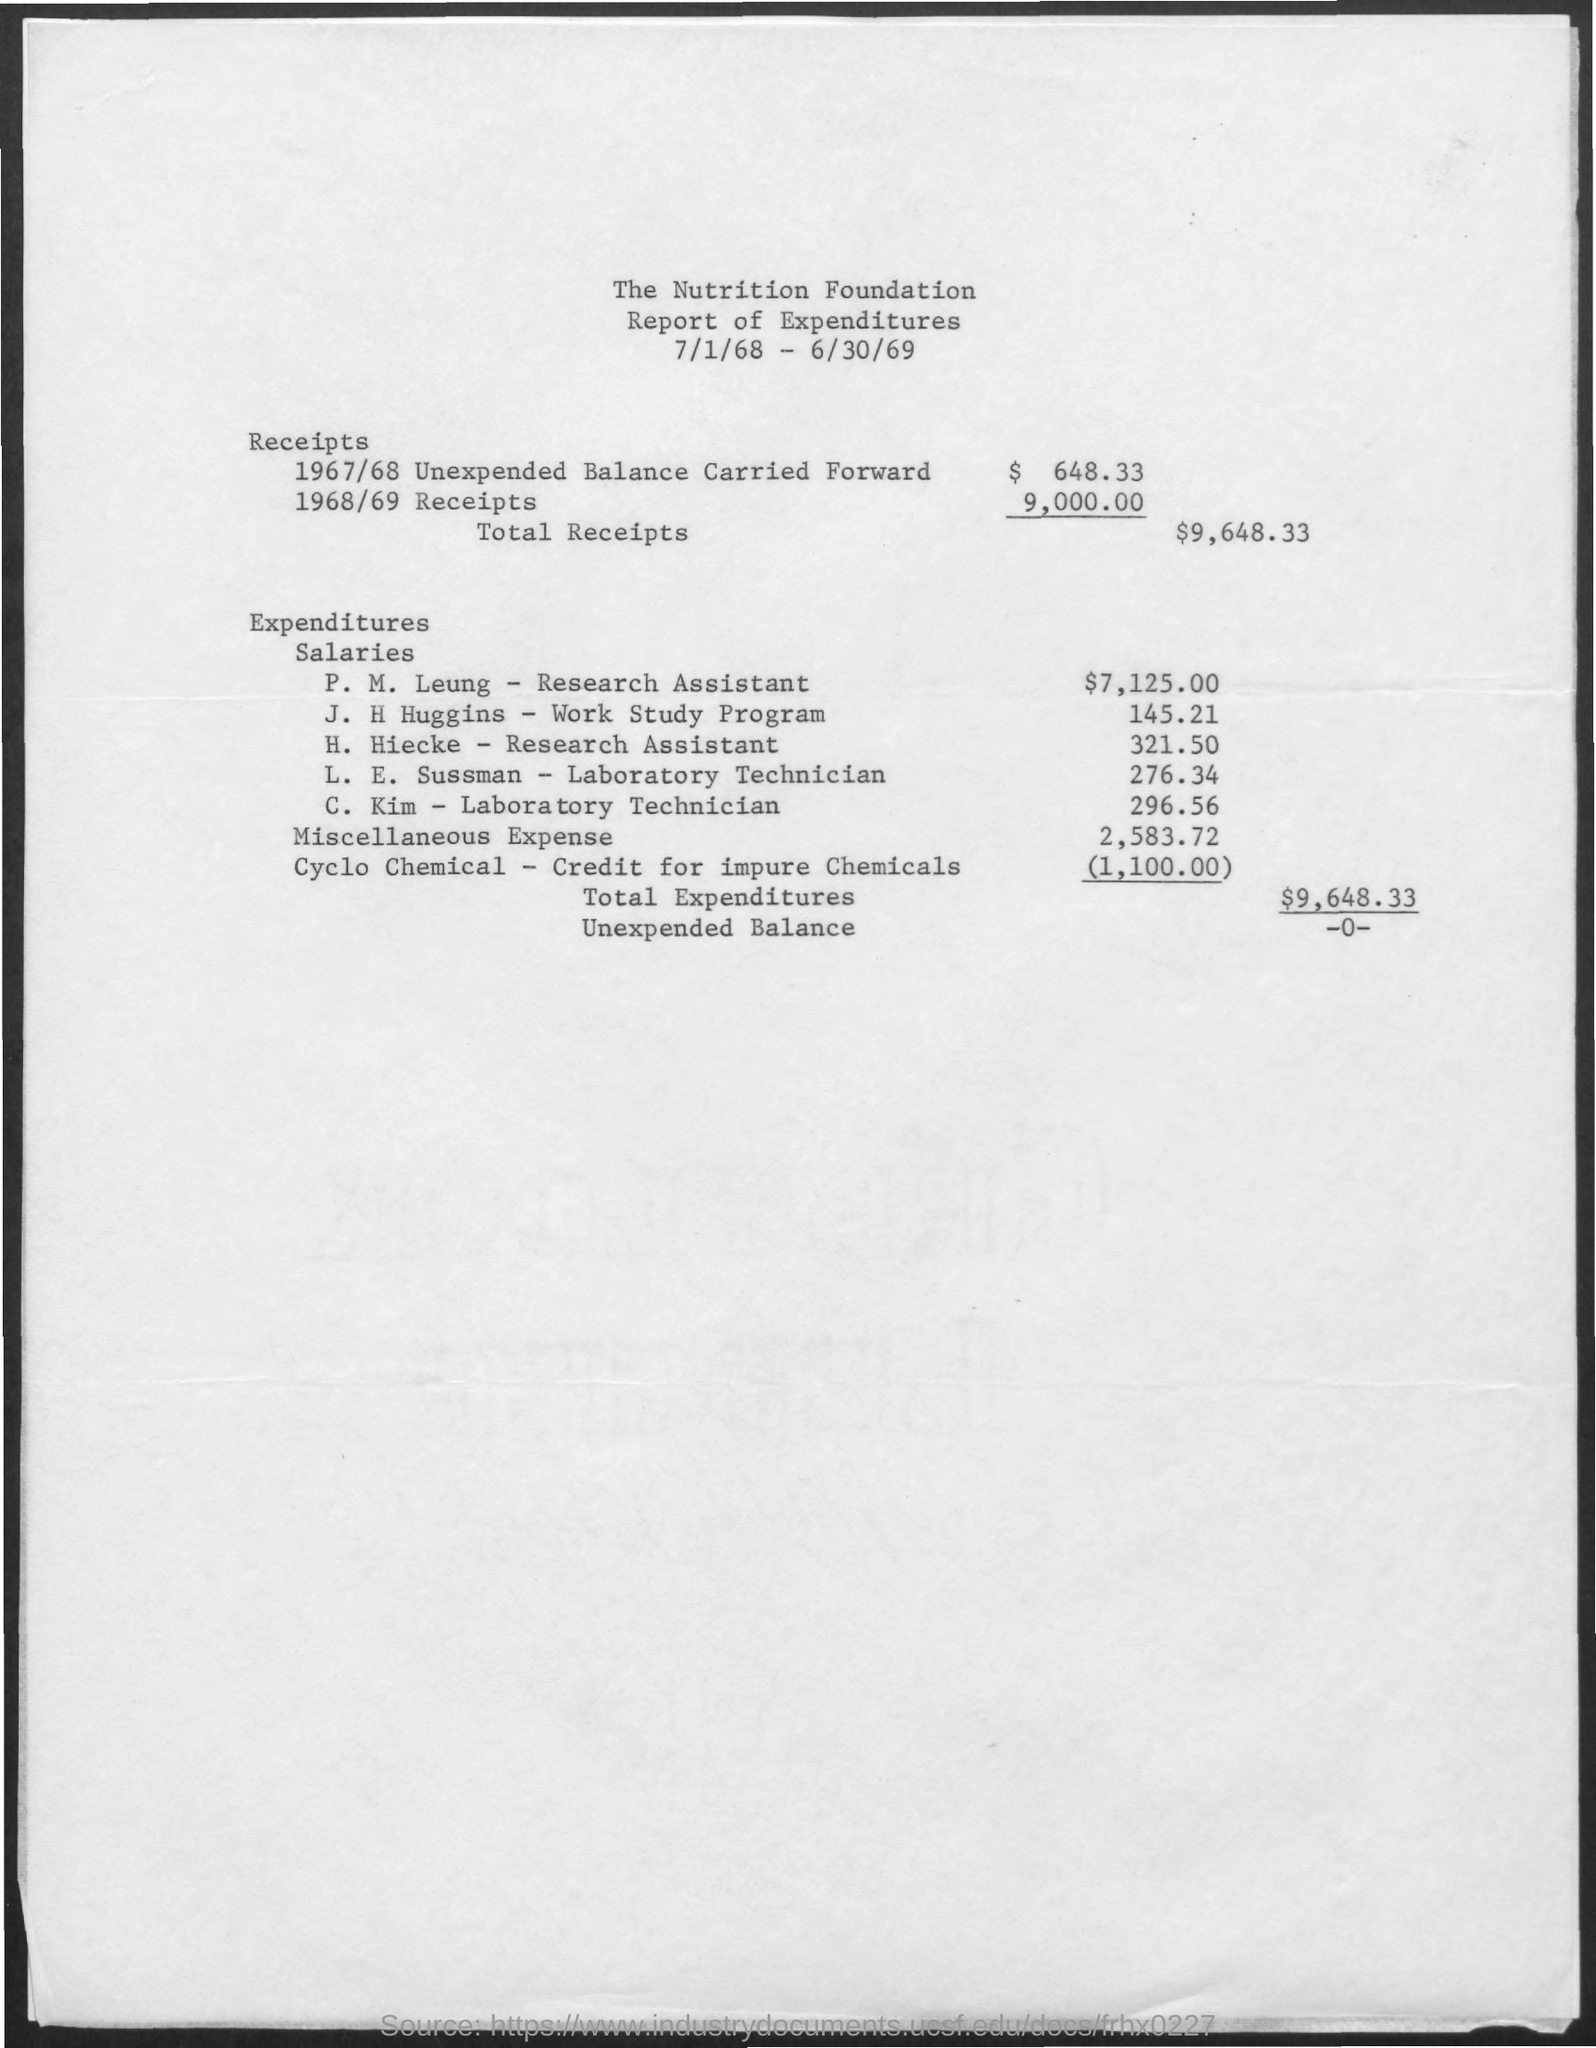What is the amount of unexpected balance carried forward for the receipts in the year 1967/68 ?
Give a very brief answer. $ 648.33. What is the amount of receipts in the year 1968/69 ?
Your response must be concise. 9,000.00. What is the amount of total receipts given in the report ?
Keep it short and to the point. $9,648.33. What is the amount of miscellaneous expense mentioned in the given report ?
Offer a very short reply. 2,583.72. What is the salary given to p.m.leung-research assistant ?
Give a very brief answer. $ 7,125.00. What is the salary given to j.h.huggins-work study program ?
Give a very brief answer. 145.21. What is the salary given to c.kim -laboratory technician ?
Keep it short and to the point. 296.56. What is the amount of total expenditures mentioned in the given report ?
Your answer should be very brief. $ 9,648.33. What is the salary given to h.hiecke - research assiatant ?
Provide a short and direct response. 321.50. What is the salary given to l.e. sussman -laboratory technician?
Provide a short and direct response. $ 276.34. 